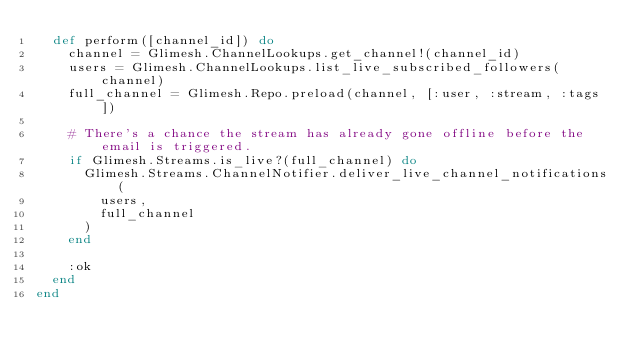<code> <loc_0><loc_0><loc_500><loc_500><_Elixir_>  def perform([channel_id]) do
    channel = Glimesh.ChannelLookups.get_channel!(channel_id)
    users = Glimesh.ChannelLookups.list_live_subscribed_followers(channel)
    full_channel = Glimesh.Repo.preload(channel, [:user, :stream, :tags])

    # There's a chance the stream has already gone offline before the email is triggered.
    if Glimesh.Streams.is_live?(full_channel) do
      Glimesh.Streams.ChannelNotifier.deliver_live_channel_notifications(
        users,
        full_channel
      )
    end

    :ok
  end
end
</code> 